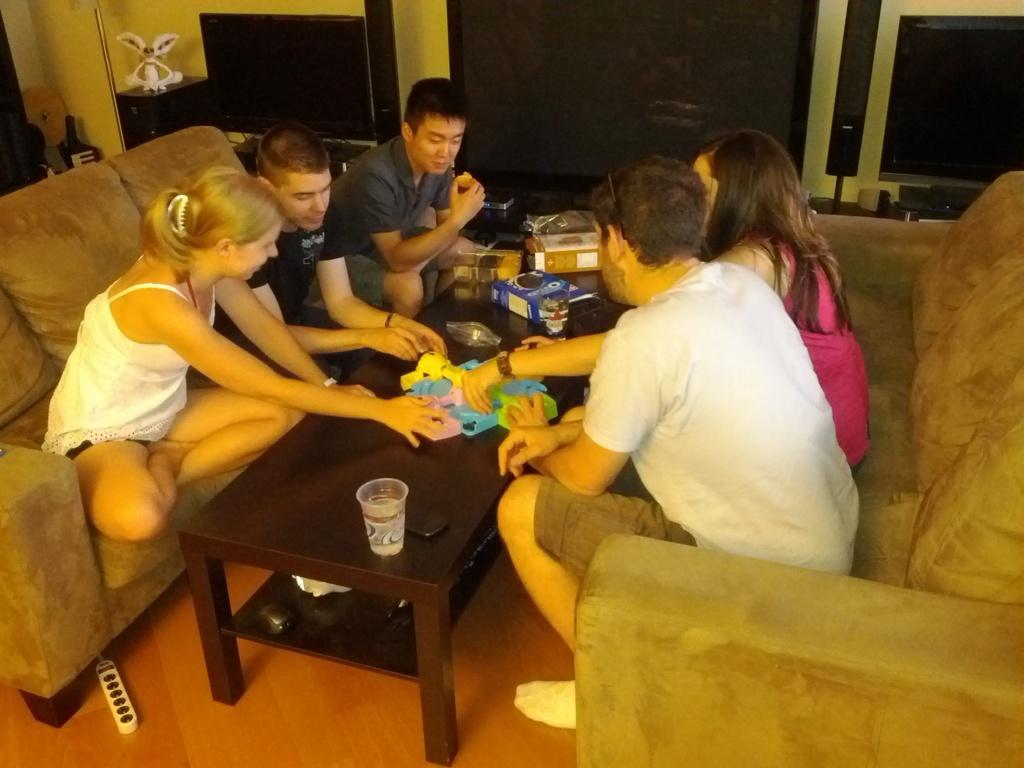Can you describe this image briefly? There are five members sitting in the sofas around the table on which some glass, toys and some boxes were placed. There are two women and three men in this group. In the background there is a television and speakers. 